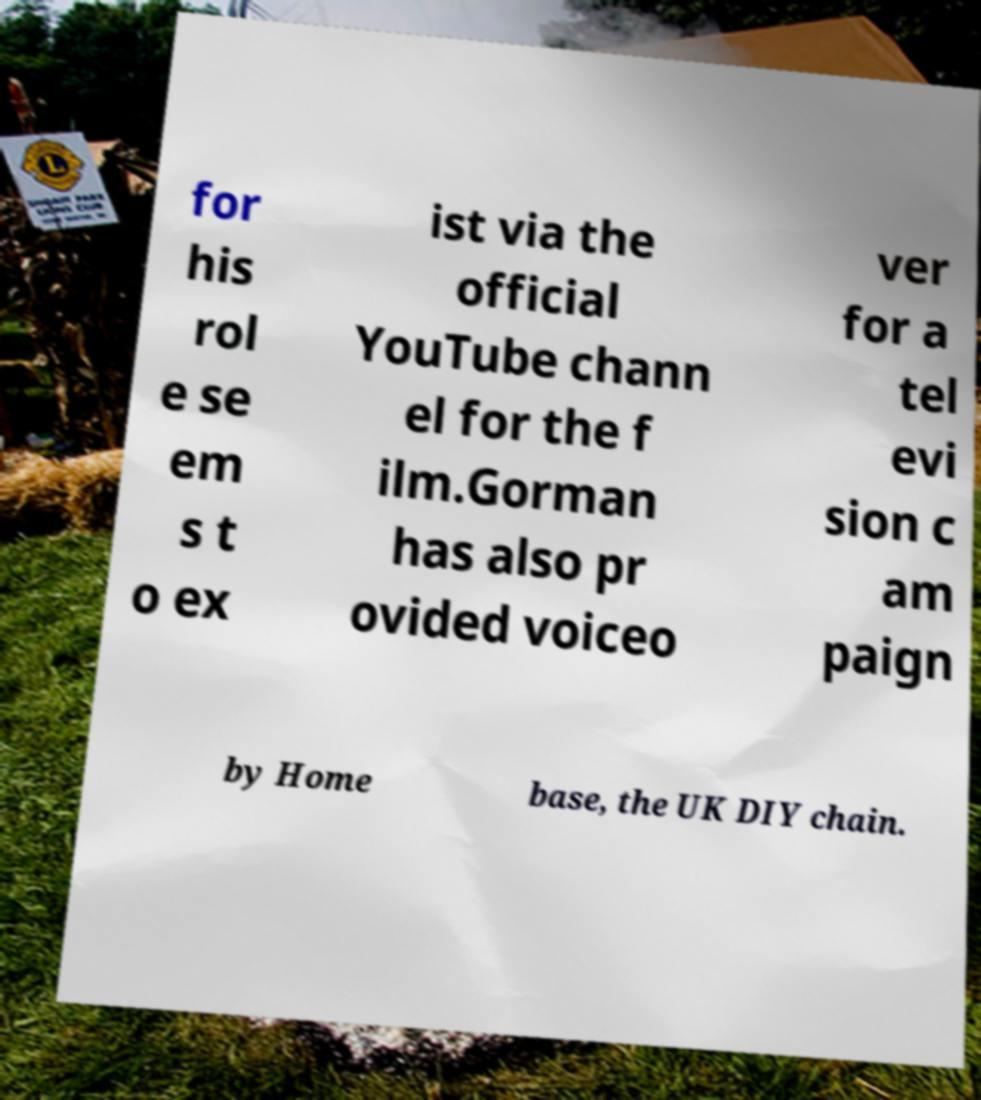I need the written content from this picture converted into text. Can you do that? for his rol e se em s t o ex ist via the official YouTube chann el for the f ilm.Gorman has also pr ovided voiceo ver for a tel evi sion c am paign by Home base, the UK DIY chain. 